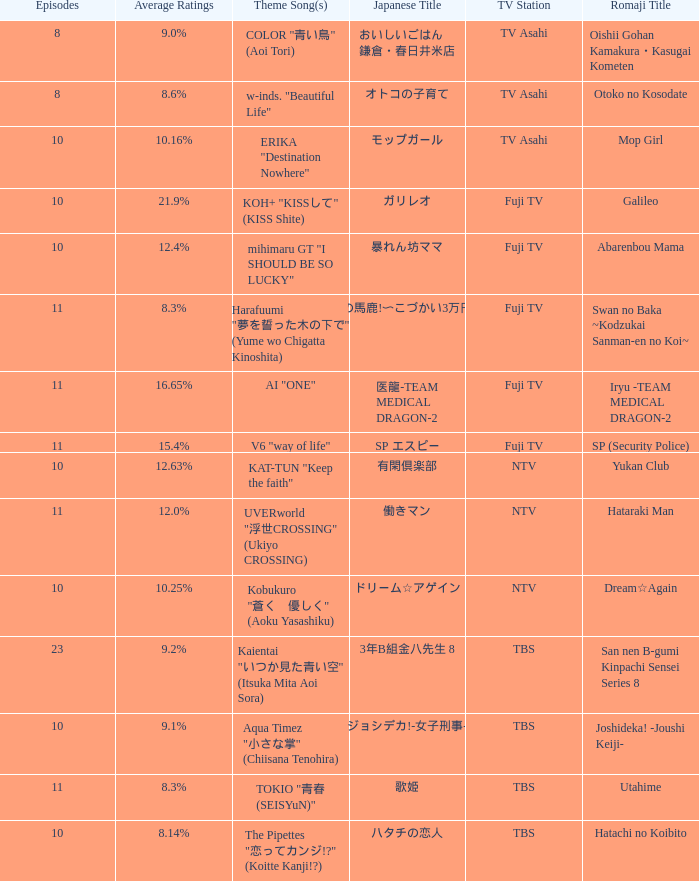What is the Theme Song of 働きマン? UVERworld "浮世CROSSING" (Ukiyo CROSSING). 